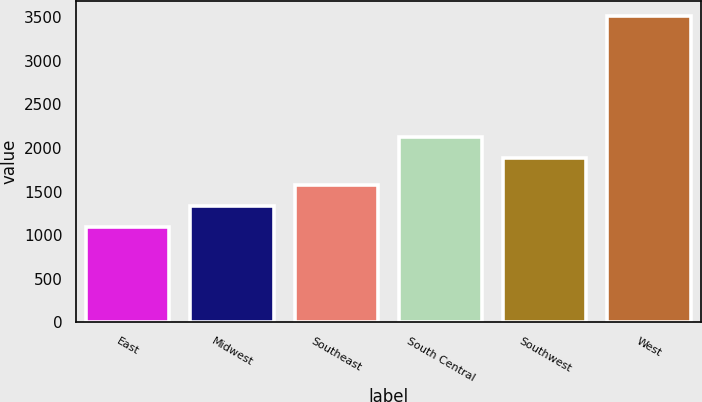Convert chart to OTSL. <chart><loc_0><loc_0><loc_500><loc_500><bar_chart><fcel>East<fcel>Midwest<fcel>Southeast<fcel>South Central<fcel>Southwest<fcel>West<nl><fcel>1092<fcel>1334.31<fcel>1576.62<fcel>2124.31<fcel>1882<fcel>3515.1<nl></chart> 